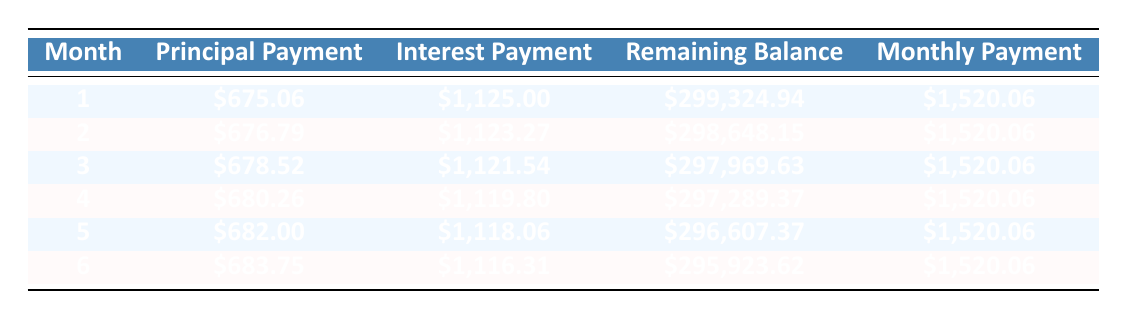What is the principal payment in month 3? The table shows that the principal payment for month 3 is listed as $678.52.
Answer: 678.52 What is the total interest payment for month 6? According to the table, the total interest payment for month 6 is $1,116.31.
Answer: 1,116.31 In which month does the principal payment exceed $680? Looking at the table, the principal payment for month 5 is $682.00, which is the first instance it exceeds $680.
Answer: Month 5 What is the remaining balance after month 2? The table indicates that the remaining balance after month 2 is $298,648.15.
Answer: 298,648.15 Is the monthly payment constant throughout the first six months? The monthly payment for all the listed months is constant at $1,520.06, indicating it does not change.
Answer: Yes What is the average principal payment for the first six months? To find the average, sum the principal payments for the first six months: (675.06 + 676.79 + 678.52 + 680.26 + 682.00 + 683.75) = 4,676.38. Then divide by 6: 4,676.38/6 = 779.40.
Answer: 779.40 How much total principal has been paid off by month 6? By month 6, we can see from the table that the cumulative principal payments total is $4,675.38.
Answer: 4,675.38 After month 1, is the remaining balance less than 300,000? The remaining balance after month 1 is $299,324.94, which is indeed less than $300,000.
Answer: Yes How much interest is paid in total over the first six months? To find the total interest paid in the first six months, add the interest payments: (1125.00 + 1123.27 + 1121.54 + 1119.80 + 1118.06 + 1116.31) = 6,825.98.
Answer: 6,825.98 